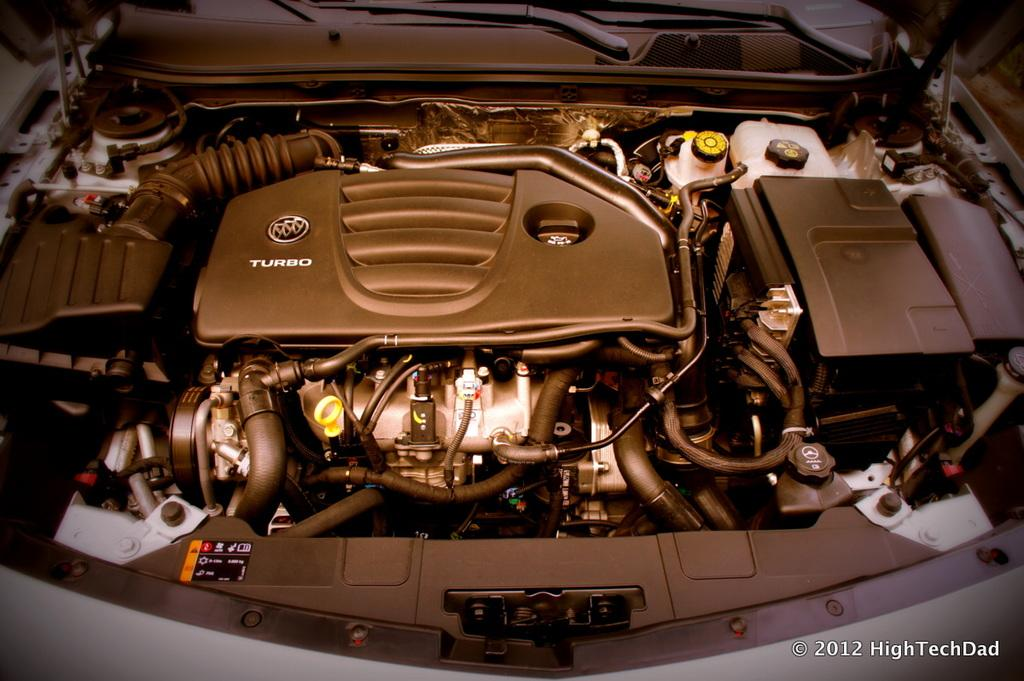Provide a one-sentence caption for the provided image. Car with the hood open showing an engine that says "Turbo". 